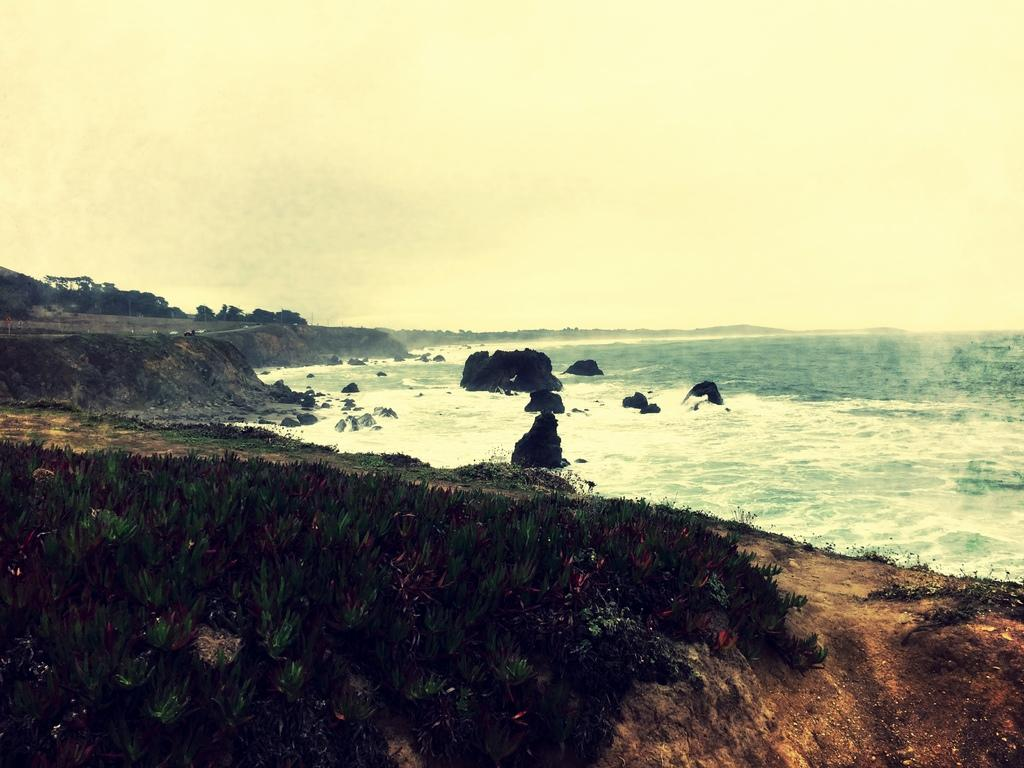What is the main subject of the image? The image depicts the sea. Are there any objects or features visible in the sea? No specific objects or features are mentioned in the sea, but there are rocks visible in the image. What type of vegetation can be seen on the surface in the image? There are plants on the surface in the image. What can be seen in the background of the image? There are trees in the background of the image. How does the dad feel about the heat in the image? There is no dad or mention of heat in the image; it depicts the sea, rocks, plants, and trees. 